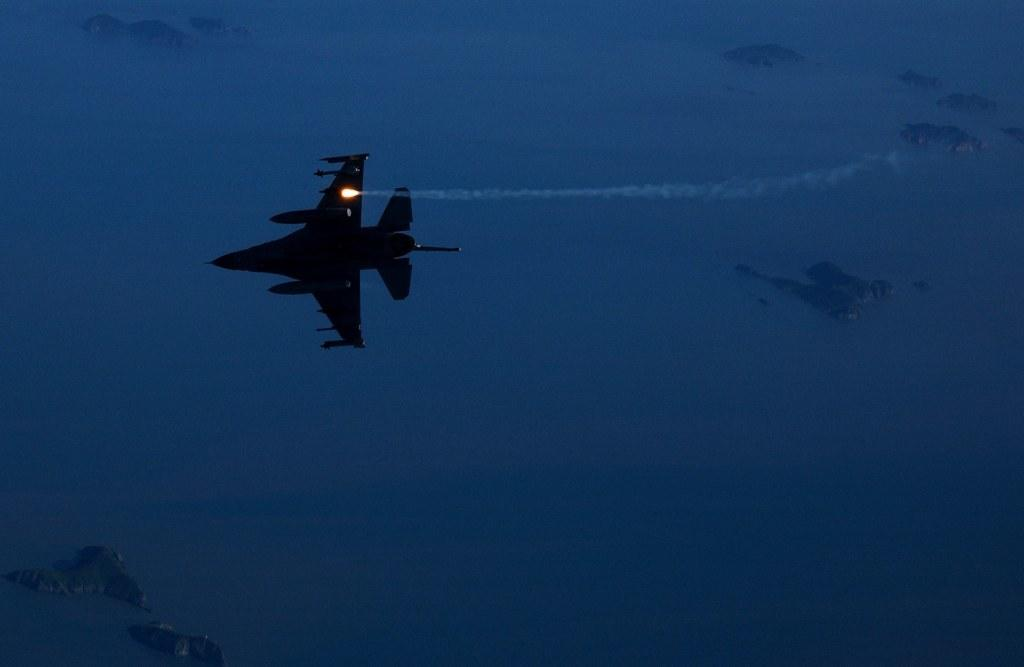What is the main subject of the image? The main subject of the image is an airplane. What is the airplane doing in the image? The airplane is flying in the image. What can be seen in the background of the image? The sky is visible in the background of the image. What type of plant is being ministered by the fiction character in the image? There is no plant, minister, or fiction character present in the image. 